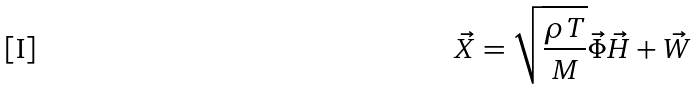Convert formula to latex. <formula><loc_0><loc_0><loc_500><loc_500>\vec { X } = \sqrt { \frac { \rho T } { M } } \vec { \Phi } \vec { H } + \vec { W }</formula> 